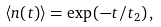Convert formula to latex. <formula><loc_0><loc_0><loc_500><loc_500>\left \langle n ( t ) \right \rangle = \exp \left ( - t / t _ { 2 } \right ) ,</formula> 